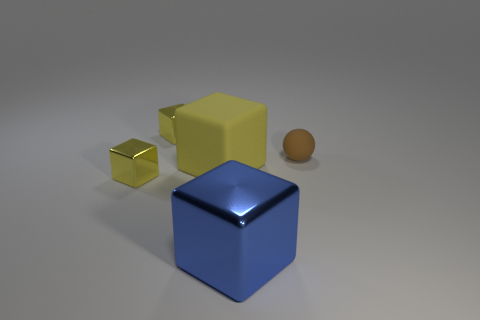What number of other yellow things are the same size as the yellow rubber thing?
Make the answer very short. 0. What is the large blue cube made of?
Keep it short and to the point. Metal. There is a matte ball; are there any small yellow metal things behind it?
Keep it short and to the point. Yes. There is a thing that is the same material as the brown ball; what size is it?
Your answer should be very brief. Large. How many small balls have the same color as the large metal block?
Make the answer very short. 0. Are there fewer brown balls that are left of the matte block than tiny brown things on the left side of the big blue thing?
Offer a terse response. No. There is a yellow metallic block in front of the brown thing; how big is it?
Provide a succinct answer. Small. Are there any big brown things made of the same material as the large yellow block?
Your answer should be compact. No. Does the large blue cube have the same material as the brown sphere?
Keep it short and to the point. No. There is another matte object that is the same size as the blue object; what color is it?
Ensure brevity in your answer.  Yellow. 